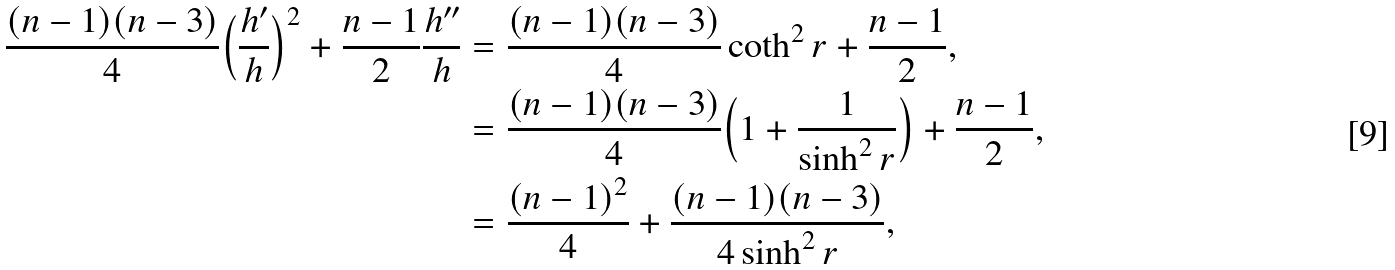<formula> <loc_0><loc_0><loc_500><loc_500>\frac { ( n - 1 ) ( n - 3 ) } { 4 } \Big { ( } \frac { h ^ { \prime } } { h } \Big { ) } ^ { 2 } + \frac { n - 1 } { 2 } \frac { h ^ { \prime \prime } } { h } & = \frac { ( n - 1 ) ( n - 3 ) } { 4 } \coth ^ { 2 } r + \frac { n - 1 } { 2 } , \\ & = \frac { ( n - 1 ) ( n - 3 ) } { 4 } \Big { ( } 1 + \frac { 1 } { \sinh ^ { 2 } r } \Big { ) } + \frac { n - 1 } { 2 } , \\ & = \frac { ( n - 1 ) ^ { 2 } } { 4 } + \frac { ( n - 1 ) ( n - 3 ) } { 4 \sinh ^ { 2 } r } ,</formula> 